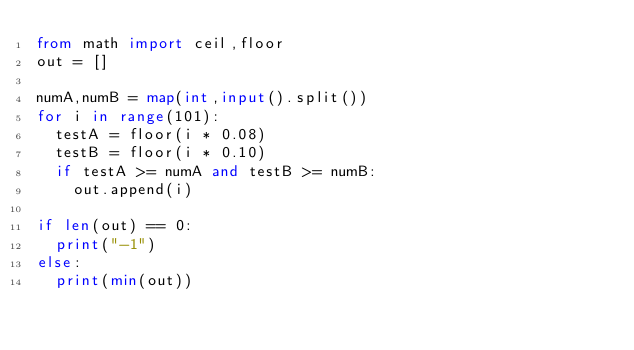<code> <loc_0><loc_0><loc_500><loc_500><_Python_>from math import ceil,floor
out = []

numA,numB = map(int,input().split())
for i in range(101):
  testA = floor(i * 0.08)
  testB = floor(i * 0.10)
  if testA >= numA and testB >= numB:
    out.append(i)

if len(out) == 0:
  print("-1")
else:
  print(min(out))</code> 